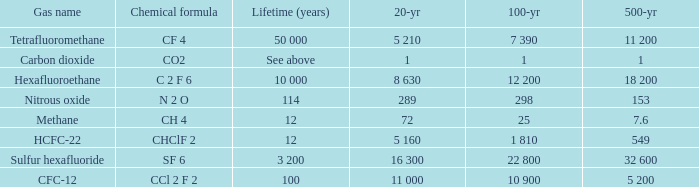What is the 100 year for Carbon Dioxide? 1.0. 